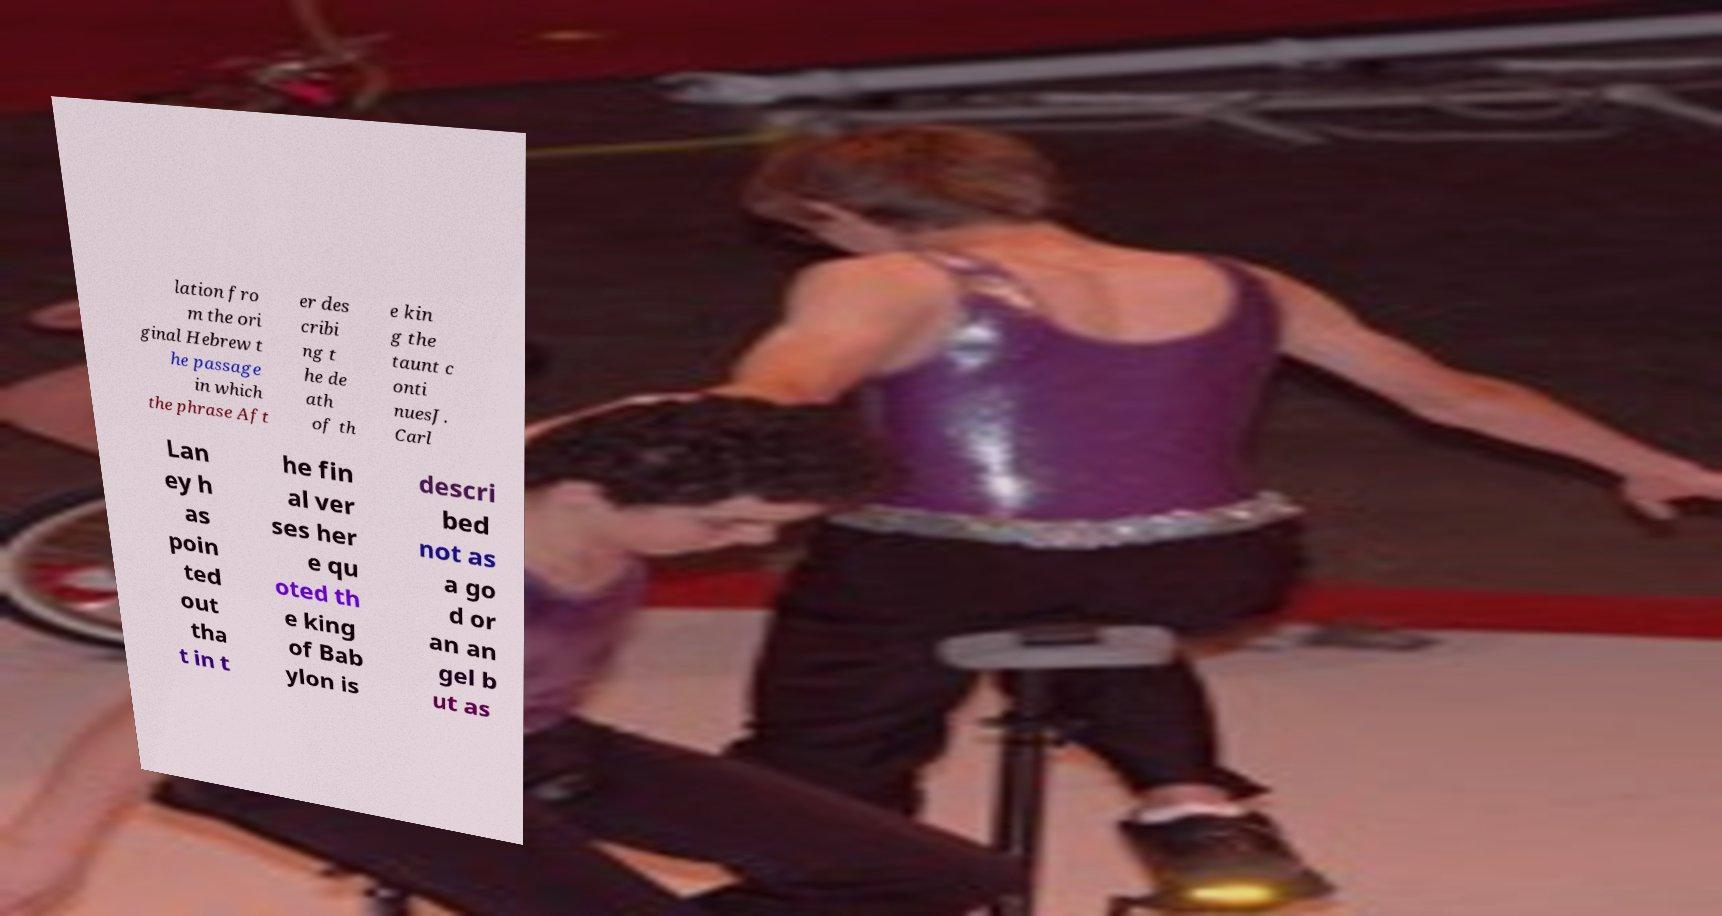Can you read and provide the text displayed in the image?This photo seems to have some interesting text. Can you extract and type it out for me? lation fro m the ori ginal Hebrew t he passage in which the phrase Aft er des cribi ng t he de ath of th e kin g the taunt c onti nuesJ. Carl Lan ey h as poin ted out tha t in t he fin al ver ses her e qu oted th e king of Bab ylon is descri bed not as a go d or an an gel b ut as 